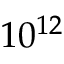Convert formula to latex. <formula><loc_0><loc_0><loc_500><loc_500>1 0 ^ { 1 2 }</formula> 